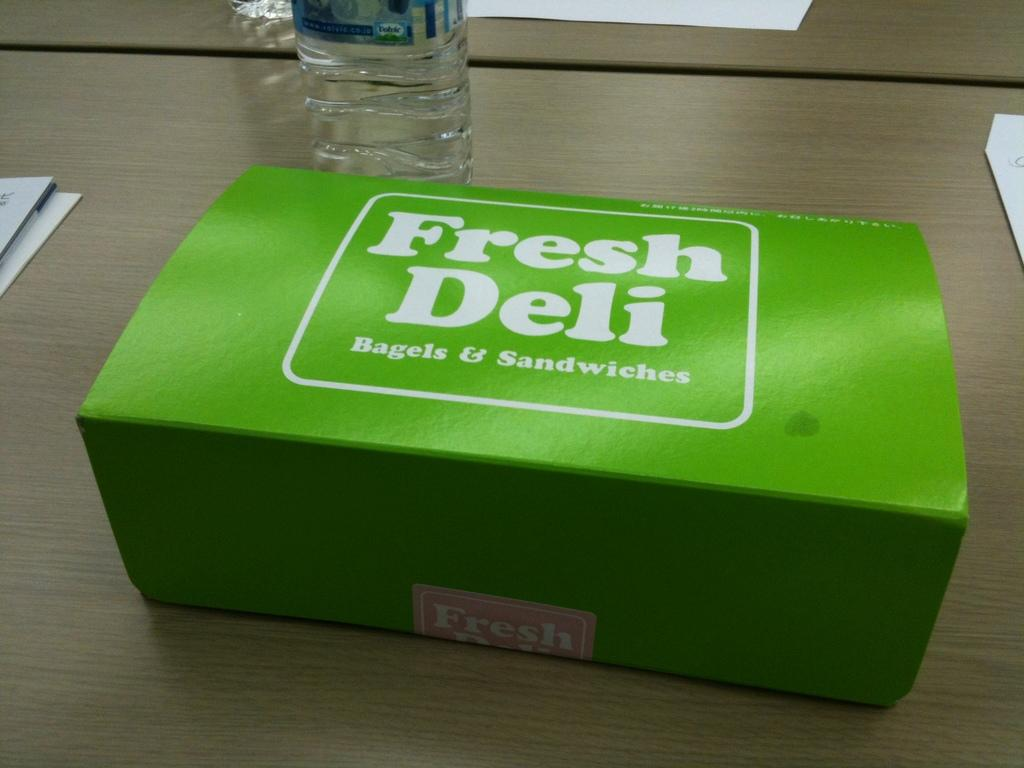Provide a one-sentence caption for the provided image. A green Fresh Deli box sitting unopened on a table. 